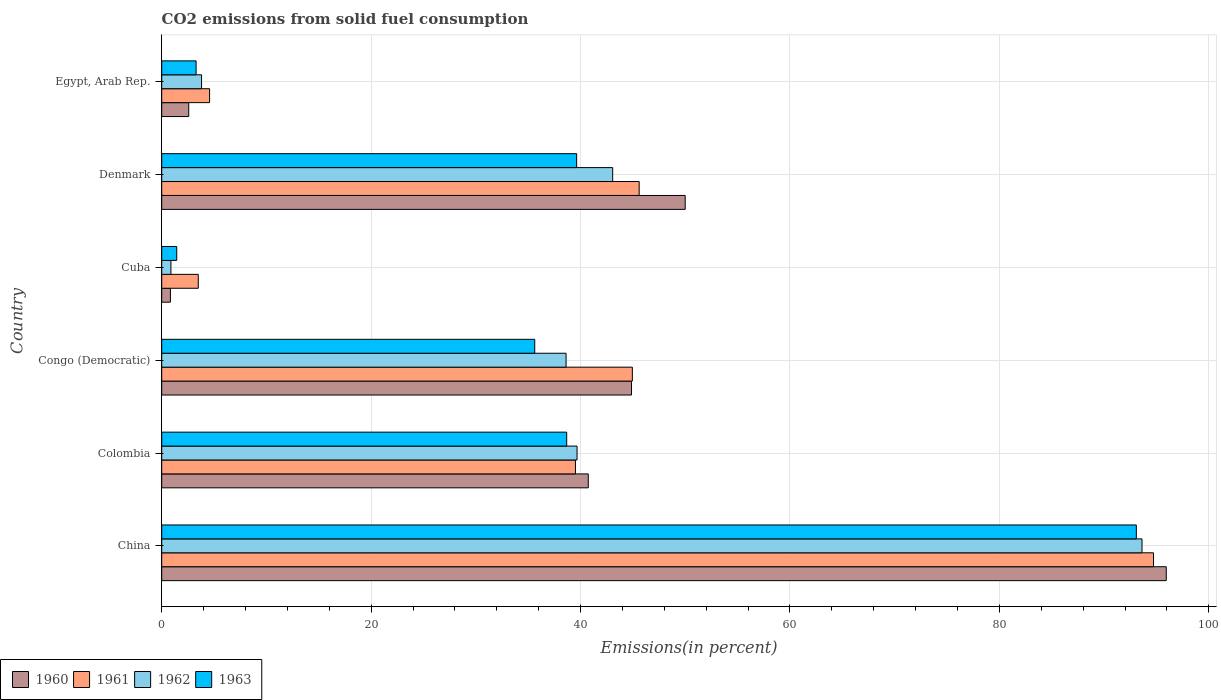How many different coloured bars are there?
Keep it short and to the point. 4. How many bars are there on the 5th tick from the bottom?
Offer a very short reply. 4. What is the label of the 6th group of bars from the top?
Your response must be concise. China. What is the total CO2 emitted in 1962 in Denmark?
Your response must be concise. 43.07. Across all countries, what is the maximum total CO2 emitted in 1960?
Provide a short and direct response. 95.93. Across all countries, what is the minimum total CO2 emitted in 1962?
Provide a succinct answer. 0.88. In which country was the total CO2 emitted in 1963 minimum?
Your answer should be very brief. Cuba. What is the total total CO2 emitted in 1962 in the graph?
Your answer should be very brief. 219.66. What is the difference between the total CO2 emitted in 1963 in Cuba and that in Egypt, Arab Rep.?
Your answer should be compact. -1.85. What is the difference between the total CO2 emitted in 1961 in Egypt, Arab Rep. and the total CO2 emitted in 1962 in Colombia?
Your answer should be very brief. -35.09. What is the average total CO2 emitted in 1963 per country?
Your answer should be compact. 35.29. What is the difference between the total CO2 emitted in 1960 and total CO2 emitted in 1962 in Egypt, Arab Rep.?
Provide a succinct answer. -1.22. What is the ratio of the total CO2 emitted in 1963 in Colombia to that in Egypt, Arab Rep.?
Keep it short and to the point. 11.78. Is the difference between the total CO2 emitted in 1960 in Colombia and Congo (Democratic) greater than the difference between the total CO2 emitted in 1962 in Colombia and Congo (Democratic)?
Make the answer very short. No. What is the difference between the highest and the second highest total CO2 emitted in 1963?
Make the answer very short. 53.45. What is the difference between the highest and the lowest total CO2 emitted in 1961?
Your response must be concise. 91.23. Is the sum of the total CO2 emitted in 1960 in Cuba and Egypt, Arab Rep. greater than the maximum total CO2 emitted in 1962 across all countries?
Your response must be concise. No. Is it the case that in every country, the sum of the total CO2 emitted in 1963 and total CO2 emitted in 1961 is greater than the sum of total CO2 emitted in 1960 and total CO2 emitted in 1962?
Offer a terse response. No. What does the 2nd bar from the top in Egypt, Arab Rep. represents?
Your answer should be very brief. 1962. What does the 3rd bar from the bottom in China represents?
Your answer should be compact. 1962. Is it the case that in every country, the sum of the total CO2 emitted in 1960 and total CO2 emitted in 1961 is greater than the total CO2 emitted in 1963?
Provide a short and direct response. Yes. Does the graph contain any zero values?
Make the answer very short. No. Does the graph contain grids?
Keep it short and to the point. Yes. Where does the legend appear in the graph?
Your answer should be very brief. Bottom left. What is the title of the graph?
Keep it short and to the point. CO2 emissions from solid fuel consumption. What is the label or title of the X-axis?
Offer a very short reply. Emissions(in percent). What is the label or title of the Y-axis?
Your response must be concise. Country. What is the Emissions(in percent) in 1960 in China?
Make the answer very short. 95.93. What is the Emissions(in percent) in 1961 in China?
Your answer should be compact. 94.72. What is the Emissions(in percent) in 1962 in China?
Keep it short and to the point. 93.62. What is the Emissions(in percent) in 1963 in China?
Ensure brevity in your answer.  93.08. What is the Emissions(in percent) in 1960 in Colombia?
Ensure brevity in your answer.  40.74. What is the Emissions(in percent) of 1961 in Colombia?
Your response must be concise. 39.51. What is the Emissions(in percent) in 1962 in Colombia?
Make the answer very short. 39.66. What is the Emissions(in percent) in 1963 in Colombia?
Keep it short and to the point. 38.68. What is the Emissions(in percent) of 1960 in Congo (Democratic)?
Your response must be concise. 44.87. What is the Emissions(in percent) in 1961 in Congo (Democratic)?
Your response must be concise. 44.95. What is the Emissions(in percent) of 1962 in Congo (Democratic)?
Your answer should be compact. 38.62. What is the Emissions(in percent) in 1963 in Congo (Democratic)?
Provide a succinct answer. 35.62. What is the Emissions(in percent) in 1960 in Cuba?
Your answer should be very brief. 0.83. What is the Emissions(in percent) of 1961 in Cuba?
Your answer should be compact. 3.49. What is the Emissions(in percent) in 1962 in Cuba?
Ensure brevity in your answer.  0.88. What is the Emissions(in percent) in 1963 in Cuba?
Give a very brief answer. 1.43. What is the Emissions(in percent) of 1960 in Denmark?
Make the answer very short. 49.99. What is the Emissions(in percent) of 1961 in Denmark?
Offer a very short reply. 45.6. What is the Emissions(in percent) of 1962 in Denmark?
Your answer should be very brief. 43.07. What is the Emissions(in percent) in 1963 in Denmark?
Your answer should be compact. 39.63. What is the Emissions(in percent) of 1960 in Egypt, Arab Rep.?
Your answer should be compact. 2.58. What is the Emissions(in percent) of 1961 in Egypt, Arab Rep.?
Your answer should be compact. 4.57. What is the Emissions(in percent) of 1962 in Egypt, Arab Rep.?
Offer a terse response. 3.81. What is the Emissions(in percent) of 1963 in Egypt, Arab Rep.?
Give a very brief answer. 3.28. Across all countries, what is the maximum Emissions(in percent) of 1960?
Offer a very short reply. 95.93. Across all countries, what is the maximum Emissions(in percent) in 1961?
Provide a short and direct response. 94.72. Across all countries, what is the maximum Emissions(in percent) in 1962?
Your answer should be compact. 93.62. Across all countries, what is the maximum Emissions(in percent) of 1963?
Provide a succinct answer. 93.08. Across all countries, what is the minimum Emissions(in percent) of 1960?
Keep it short and to the point. 0.83. Across all countries, what is the minimum Emissions(in percent) in 1961?
Your answer should be very brief. 3.49. Across all countries, what is the minimum Emissions(in percent) in 1962?
Ensure brevity in your answer.  0.88. Across all countries, what is the minimum Emissions(in percent) of 1963?
Provide a short and direct response. 1.43. What is the total Emissions(in percent) in 1960 in the graph?
Offer a very short reply. 234.94. What is the total Emissions(in percent) of 1961 in the graph?
Provide a short and direct response. 232.84. What is the total Emissions(in percent) of 1962 in the graph?
Give a very brief answer. 219.66. What is the total Emissions(in percent) in 1963 in the graph?
Offer a terse response. 211.72. What is the difference between the Emissions(in percent) in 1960 in China and that in Colombia?
Provide a short and direct response. 55.2. What is the difference between the Emissions(in percent) in 1961 in China and that in Colombia?
Make the answer very short. 55.2. What is the difference between the Emissions(in percent) in 1962 in China and that in Colombia?
Make the answer very short. 53.96. What is the difference between the Emissions(in percent) in 1963 in China and that in Colombia?
Make the answer very short. 54.4. What is the difference between the Emissions(in percent) of 1960 in China and that in Congo (Democratic)?
Offer a very short reply. 51.07. What is the difference between the Emissions(in percent) of 1961 in China and that in Congo (Democratic)?
Give a very brief answer. 49.77. What is the difference between the Emissions(in percent) in 1962 in China and that in Congo (Democratic)?
Your answer should be very brief. 55. What is the difference between the Emissions(in percent) in 1963 in China and that in Congo (Democratic)?
Give a very brief answer. 57.45. What is the difference between the Emissions(in percent) in 1960 in China and that in Cuba?
Provide a short and direct response. 95.11. What is the difference between the Emissions(in percent) in 1961 in China and that in Cuba?
Offer a terse response. 91.23. What is the difference between the Emissions(in percent) in 1962 in China and that in Cuba?
Provide a succinct answer. 92.74. What is the difference between the Emissions(in percent) in 1963 in China and that in Cuba?
Provide a succinct answer. 91.64. What is the difference between the Emissions(in percent) in 1960 in China and that in Denmark?
Ensure brevity in your answer.  45.94. What is the difference between the Emissions(in percent) in 1961 in China and that in Denmark?
Your response must be concise. 49.12. What is the difference between the Emissions(in percent) in 1962 in China and that in Denmark?
Provide a short and direct response. 50.55. What is the difference between the Emissions(in percent) of 1963 in China and that in Denmark?
Provide a short and direct response. 53.45. What is the difference between the Emissions(in percent) in 1960 in China and that in Egypt, Arab Rep.?
Your answer should be compact. 93.35. What is the difference between the Emissions(in percent) in 1961 in China and that in Egypt, Arab Rep.?
Give a very brief answer. 90.15. What is the difference between the Emissions(in percent) in 1962 in China and that in Egypt, Arab Rep.?
Offer a very short reply. 89.81. What is the difference between the Emissions(in percent) in 1963 in China and that in Egypt, Arab Rep.?
Provide a succinct answer. 89.79. What is the difference between the Emissions(in percent) in 1960 in Colombia and that in Congo (Democratic)?
Provide a short and direct response. -4.13. What is the difference between the Emissions(in percent) of 1961 in Colombia and that in Congo (Democratic)?
Provide a succinct answer. -5.43. What is the difference between the Emissions(in percent) of 1962 in Colombia and that in Congo (Democratic)?
Provide a succinct answer. 1.05. What is the difference between the Emissions(in percent) of 1963 in Colombia and that in Congo (Democratic)?
Offer a terse response. 3.05. What is the difference between the Emissions(in percent) in 1960 in Colombia and that in Cuba?
Give a very brief answer. 39.91. What is the difference between the Emissions(in percent) of 1961 in Colombia and that in Cuba?
Provide a succinct answer. 36.02. What is the difference between the Emissions(in percent) of 1962 in Colombia and that in Cuba?
Keep it short and to the point. 38.78. What is the difference between the Emissions(in percent) in 1963 in Colombia and that in Cuba?
Provide a succinct answer. 37.24. What is the difference between the Emissions(in percent) in 1960 in Colombia and that in Denmark?
Offer a terse response. -9.26. What is the difference between the Emissions(in percent) of 1961 in Colombia and that in Denmark?
Give a very brief answer. -6.08. What is the difference between the Emissions(in percent) in 1962 in Colombia and that in Denmark?
Provide a succinct answer. -3.4. What is the difference between the Emissions(in percent) of 1963 in Colombia and that in Denmark?
Provide a short and direct response. -0.95. What is the difference between the Emissions(in percent) in 1960 in Colombia and that in Egypt, Arab Rep.?
Offer a very short reply. 38.16. What is the difference between the Emissions(in percent) of 1961 in Colombia and that in Egypt, Arab Rep.?
Ensure brevity in your answer.  34.94. What is the difference between the Emissions(in percent) of 1962 in Colombia and that in Egypt, Arab Rep.?
Offer a very short reply. 35.86. What is the difference between the Emissions(in percent) in 1963 in Colombia and that in Egypt, Arab Rep.?
Keep it short and to the point. 35.39. What is the difference between the Emissions(in percent) in 1960 in Congo (Democratic) and that in Cuba?
Make the answer very short. 44.04. What is the difference between the Emissions(in percent) of 1961 in Congo (Democratic) and that in Cuba?
Ensure brevity in your answer.  41.45. What is the difference between the Emissions(in percent) in 1962 in Congo (Democratic) and that in Cuba?
Give a very brief answer. 37.74. What is the difference between the Emissions(in percent) in 1963 in Congo (Democratic) and that in Cuba?
Offer a terse response. 34.19. What is the difference between the Emissions(in percent) of 1960 in Congo (Democratic) and that in Denmark?
Provide a short and direct response. -5.13. What is the difference between the Emissions(in percent) in 1961 in Congo (Democratic) and that in Denmark?
Your answer should be compact. -0.65. What is the difference between the Emissions(in percent) in 1962 in Congo (Democratic) and that in Denmark?
Provide a short and direct response. -4.45. What is the difference between the Emissions(in percent) in 1963 in Congo (Democratic) and that in Denmark?
Make the answer very short. -4. What is the difference between the Emissions(in percent) in 1960 in Congo (Democratic) and that in Egypt, Arab Rep.?
Keep it short and to the point. 42.28. What is the difference between the Emissions(in percent) in 1961 in Congo (Democratic) and that in Egypt, Arab Rep.?
Your answer should be compact. 40.37. What is the difference between the Emissions(in percent) of 1962 in Congo (Democratic) and that in Egypt, Arab Rep.?
Give a very brief answer. 34.81. What is the difference between the Emissions(in percent) of 1963 in Congo (Democratic) and that in Egypt, Arab Rep.?
Make the answer very short. 32.34. What is the difference between the Emissions(in percent) in 1960 in Cuba and that in Denmark?
Provide a succinct answer. -49.16. What is the difference between the Emissions(in percent) of 1961 in Cuba and that in Denmark?
Provide a short and direct response. -42.11. What is the difference between the Emissions(in percent) of 1962 in Cuba and that in Denmark?
Your answer should be very brief. -42.19. What is the difference between the Emissions(in percent) in 1963 in Cuba and that in Denmark?
Your answer should be very brief. -38.19. What is the difference between the Emissions(in percent) of 1960 in Cuba and that in Egypt, Arab Rep.?
Your answer should be compact. -1.75. What is the difference between the Emissions(in percent) in 1961 in Cuba and that in Egypt, Arab Rep.?
Offer a very short reply. -1.08. What is the difference between the Emissions(in percent) of 1962 in Cuba and that in Egypt, Arab Rep.?
Offer a very short reply. -2.93. What is the difference between the Emissions(in percent) of 1963 in Cuba and that in Egypt, Arab Rep.?
Make the answer very short. -1.85. What is the difference between the Emissions(in percent) in 1960 in Denmark and that in Egypt, Arab Rep.?
Provide a short and direct response. 47.41. What is the difference between the Emissions(in percent) in 1961 in Denmark and that in Egypt, Arab Rep.?
Your answer should be very brief. 41.03. What is the difference between the Emissions(in percent) of 1962 in Denmark and that in Egypt, Arab Rep.?
Your response must be concise. 39.26. What is the difference between the Emissions(in percent) in 1963 in Denmark and that in Egypt, Arab Rep.?
Offer a very short reply. 36.34. What is the difference between the Emissions(in percent) of 1960 in China and the Emissions(in percent) of 1961 in Colombia?
Your answer should be compact. 56.42. What is the difference between the Emissions(in percent) of 1960 in China and the Emissions(in percent) of 1962 in Colombia?
Your answer should be compact. 56.27. What is the difference between the Emissions(in percent) of 1960 in China and the Emissions(in percent) of 1963 in Colombia?
Keep it short and to the point. 57.26. What is the difference between the Emissions(in percent) of 1961 in China and the Emissions(in percent) of 1962 in Colombia?
Provide a short and direct response. 55.05. What is the difference between the Emissions(in percent) in 1961 in China and the Emissions(in percent) in 1963 in Colombia?
Make the answer very short. 56.04. What is the difference between the Emissions(in percent) in 1962 in China and the Emissions(in percent) in 1963 in Colombia?
Keep it short and to the point. 54.94. What is the difference between the Emissions(in percent) in 1960 in China and the Emissions(in percent) in 1961 in Congo (Democratic)?
Your answer should be compact. 50.99. What is the difference between the Emissions(in percent) in 1960 in China and the Emissions(in percent) in 1962 in Congo (Democratic)?
Give a very brief answer. 57.32. What is the difference between the Emissions(in percent) in 1960 in China and the Emissions(in percent) in 1963 in Congo (Democratic)?
Give a very brief answer. 60.31. What is the difference between the Emissions(in percent) of 1961 in China and the Emissions(in percent) of 1962 in Congo (Democratic)?
Make the answer very short. 56.1. What is the difference between the Emissions(in percent) of 1961 in China and the Emissions(in percent) of 1963 in Congo (Democratic)?
Provide a succinct answer. 59.09. What is the difference between the Emissions(in percent) of 1962 in China and the Emissions(in percent) of 1963 in Congo (Democratic)?
Give a very brief answer. 58. What is the difference between the Emissions(in percent) of 1960 in China and the Emissions(in percent) of 1961 in Cuba?
Make the answer very short. 92.44. What is the difference between the Emissions(in percent) in 1960 in China and the Emissions(in percent) in 1962 in Cuba?
Offer a terse response. 95.05. What is the difference between the Emissions(in percent) of 1960 in China and the Emissions(in percent) of 1963 in Cuba?
Your response must be concise. 94.5. What is the difference between the Emissions(in percent) in 1961 in China and the Emissions(in percent) in 1962 in Cuba?
Keep it short and to the point. 93.84. What is the difference between the Emissions(in percent) in 1961 in China and the Emissions(in percent) in 1963 in Cuba?
Offer a terse response. 93.28. What is the difference between the Emissions(in percent) in 1962 in China and the Emissions(in percent) in 1963 in Cuba?
Make the answer very short. 92.19. What is the difference between the Emissions(in percent) in 1960 in China and the Emissions(in percent) in 1961 in Denmark?
Your answer should be very brief. 50.34. What is the difference between the Emissions(in percent) of 1960 in China and the Emissions(in percent) of 1962 in Denmark?
Offer a terse response. 52.87. What is the difference between the Emissions(in percent) of 1960 in China and the Emissions(in percent) of 1963 in Denmark?
Offer a terse response. 56.31. What is the difference between the Emissions(in percent) in 1961 in China and the Emissions(in percent) in 1962 in Denmark?
Ensure brevity in your answer.  51.65. What is the difference between the Emissions(in percent) of 1961 in China and the Emissions(in percent) of 1963 in Denmark?
Provide a short and direct response. 55.09. What is the difference between the Emissions(in percent) of 1962 in China and the Emissions(in percent) of 1963 in Denmark?
Give a very brief answer. 53.99. What is the difference between the Emissions(in percent) of 1960 in China and the Emissions(in percent) of 1961 in Egypt, Arab Rep.?
Ensure brevity in your answer.  91.36. What is the difference between the Emissions(in percent) in 1960 in China and the Emissions(in percent) in 1962 in Egypt, Arab Rep.?
Provide a succinct answer. 92.13. What is the difference between the Emissions(in percent) of 1960 in China and the Emissions(in percent) of 1963 in Egypt, Arab Rep.?
Ensure brevity in your answer.  92.65. What is the difference between the Emissions(in percent) in 1961 in China and the Emissions(in percent) in 1962 in Egypt, Arab Rep.?
Your answer should be compact. 90.91. What is the difference between the Emissions(in percent) of 1961 in China and the Emissions(in percent) of 1963 in Egypt, Arab Rep.?
Make the answer very short. 91.43. What is the difference between the Emissions(in percent) in 1962 in China and the Emissions(in percent) in 1963 in Egypt, Arab Rep.?
Keep it short and to the point. 90.34. What is the difference between the Emissions(in percent) of 1960 in Colombia and the Emissions(in percent) of 1961 in Congo (Democratic)?
Offer a very short reply. -4.21. What is the difference between the Emissions(in percent) of 1960 in Colombia and the Emissions(in percent) of 1962 in Congo (Democratic)?
Your answer should be compact. 2.12. What is the difference between the Emissions(in percent) in 1960 in Colombia and the Emissions(in percent) in 1963 in Congo (Democratic)?
Offer a terse response. 5.11. What is the difference between the Emissions(in percent) of 1961 in Colombia and the Emissions(in percent) of 1962 in Congo (Democratic)?
Your answer should be compact. 0.9. What is the difference between the Emissions(in percent) of 1961 in Colombia and the Emissions(in percent) of 1963 in Congo (Democratic)?
Give a very brief answer. 3.89. What is the difference between the Emissions(in percent) of 1962 in Colombia and the Emissions(in percent) of 1963 in Congo (Democratic)?
Give a very brief answer. 4.04. What is the difference between the Emissions(in percent) of 1960 in Colombia and the Emissions(in percent) of 1961 in Cuba?
Give a very brief answer. 37.25. What is the difference between the Emissions(in percent) of 1960 in Colombia and the Emissions(in percent) of 1962 in Cuba?
Ensure brevity in your answer.  39.86. What is the difference between the Emissions(in percent) of 1960 in Colombia and the Emissions(in percent) of 1963 in Cuba?
Make the answer very short. 39.3. What is the difference between the Emissions(in percent) in 1961 in Colombia and the Emissions(in percent) in 1962 in Cuba?
Offer a terse response. 38.63. What is the difference between the Emissions(in percent) of 1961 in Colombia and the Emissions(in percent) of 1963 in Cuba?
Your answer should be compact. 38.08. What is the difference between the Emissions(in percent) in 1962 in Colombia and the Emissions(in percent) in 1963 in Cuba?
Your answer should be very brief. 38.23. What is the difference between the Emissions(in percent) of 1960 in Colombia and the Emissions(in percent) of 1961 in Denmark?
Make the answer very short. -4.86. What is the difference between the Emissions(in percent) in 1960 in Colombia and the Emissions(in percent) in 1962 in Denmark?
Offer a very short reply. -2.33. What is the difference between the Emissions(in percent) in 1960 in Colombia and the Emissions(in percent) in 1963 in Denmark?
Your answer should be compact. 1.11. What is the difference between the Emissions(in percent) of 1961 in Colombia and the Emissions(in percent) of 1962 in Denmark?
Keep it short and to the point. -3.56. What is the difference between the Emissions(in percent) in 1961 in Colombia and the Emissions(in percent) in 1963 in Denmark?
Ensure brevity in your answer.  -0.11. What is the difference between the Emissions(in percent) in 1962 in Colombia and the Emissions(in percent) in 1963 in Denmark?
Your response must be concise. 0.04. What is the difference between the Emissions(in percent) in 1960 in Colombia and the Emissions(in percent) in 1961 in Egypt, Arab Rep.?
Give a very brief answer. 36.17. What is the difference between the Emissions(in percent) of 1960 in Colombia and the Emissions(in percent) of 1962 in Egypt, Arab Rep.?
Your answer should be compact. 36.93. What is the difference between the Emissions(in percent) of 1960 in Colombia and the Emissions(in percent) of 1963 in Egypt, Arab Rep.?
Your answer should be very brief. 37.45. What is the difference between the Emissions(in percent) of 1961 in Colombia and the Emissions(in percent) of 1962 in Egypt, Arab Rep.?
Your answer should be compact. 35.71. What is the difference between the Emissions(in percent) of 1961 in Colombia and the Emissions(in percent) of 1963 in Egypt, Arab Rep.?
Provide a succinct answer. 36.23. What is the difference between the Emissions(in percent) of 1962 in Colombia and the Emissions(in percent) of 1963 in Egypt, Arab Rep.?
Make the answer very short. 36.38. What is the difference between the Emissions(in percent) of 1960 in Congo (Democratic) and the Emissions(in percent) of 1961 in Cuba?
Provide a succinct answer. 41.37. What is the difference between the Emissions(in percent) in 1960 in Congo (Democratic) and the Emissions(in percent) in 1962 in Cuba?
Your answer should be very brief. 43.99. What is the difference between the Emissions(in percent) in 1960 in Congo (Democratic) and the Emissions(in percent) in 1963 in Cuba?
Offer a terse response. 43.43. What is the difference between the Emissions(in percent) in 1961 in Congo (Democratic) and the Emissions(in percent) in 1962 in Cuba?
Offer a terse response. 44.07. What is the difference between the Emissions(in percent) in 1961 in Congo (Democratic) and the Emissions(in percent) in 1963 in Cuba?
Give a very brief answer. 43.51. What is the difference between the Emissions(in percent) in 1962 in Congo (Democratic) and the Emissions(in percent) in 1963 in Cuba?
Provide a succinct answer. 37.18. What is the difference between the Emissions(in percent) of 1960 in Congo (Democratic) and the Emissions(in percent) of 1961 in Denmark?
Offer a terse response. -0.73. What is the difference between the Emissions(in percent) in 1960 in Congo (Democratic) and the Emissions(in percent) in 1962 in Denmark?
Your answer should be compact. 1.8. What is the difference between the Emissions(in percent) in 1960 in Congo (Democratic) and the Emissions(in percent) in 1963 in Denmark?
Make the answer very short. 5.24. What is the difference between the Emissions(in percent) of 1961 in Congo (Democratic) and the Emissions(in percent) of 1962 in Denmark?
Your response must be concise. 1.88. What is the difference between the Emissions(in percent) of 1961 in Congo (Democratic) and the Emissions(in percent) of 1963 in Denmark?
Make the answer very short. 5.32. What is the difference between the Emissions(in percent) in 1962 in Congo (Democratic) and the Emissions(in percent) in 1963 in Denmark?
Keep it short and to the point. -1.01. What is the difference between the Emissions(in percent) in 1960 in Congo (Democratic) and the Emissions(in percent) in 1961 in Egypt, Arab Rep.?
Give a very brief answer. 40.29. What is the difference between the Emissions(in percent) of 1960 in Congo (Democratic) and the Emissions(in percent) of 1962 in Egypt, Arab Rep.?
Offer a very short reply. 41.06. What is the difference between the Emissions(in percent) in 1960 in Congo (Democratic) and the Emissions(in percent) in 1963 in Egypt, Arab Rep.?
Make the answer very short. 41.58. What is the difference between the Emissions(in percent) in 1961 in Congo (Democratic) and the Emissions(in percent) in 1962 in Egypt, Arab Rep.?
Your answer should be very brief. 41.14. What is the difference between the Emissions(in percent) in 1961 in Congo (Democratic) and the Emissions(in percent) in 1963 in Egypt, Arab Rep.?
Provide a succinct answer. 41.66. What is the difference between the Emissions(in percent) in 1962 in Congo (Democratic) and the Emissions(in percent) in 1963 in Egypt, Arab Rep.?
Ensure brevity in your answer.  35.33. What is the difference between the Emissions(in percent) of 1960 in Cuba and the Emissions(in percent) of 1961 in Denmark?
Your response must be concise. -44.77. What is the difference between the Emissions(in percent) of 1960 in Cuba and the Emissions(in percent) of 1962 in Denmark?
Your answer should be compact. -42.24. What is the difference between the Emissions(in percent) in 1960 in Cuba and the Emissions(in percent) in 1963 in Denmark?
Provide a short and direct response. -38.8. What is the difference between the Emissions(in percent) in 1961 in Cuba and the Emissions(in percent) in 1962 in Denmark?
Keep it short and to the point. -39.58. What is the difference between the Emissions(in percent) in 1961 in Cuba and the Emissions(in percent) in 1963 in Denmark?
Your answer should be very brief. -36.14. What is the difference between the Emissions(in percent) in 1962 in Cuba and the Emissions(in percent) in 1963 in Denmark?
Offer a very short reply. -38.75. What is the difference between the Emissions(in percent) in 1960 in Cuba and the Emissions(in percent) in 1961 in Egypt, Arab Rep.?
Provide a short and direct response. -3.74. What is the difference between the Emissions(in percent) in 1960 in Cuba and the Emissions(in percent) in 1962 in Egypt, Arab Rep.?
Your answer should be very brief. -2.98. What is the difference between the Emissions(in percent) in 1960 in Cuba and the Emissions(in percent) in 1963 in Egypt, Arab Rep.?
Your response must be concise. -2.45. What is the difference between the Emissions(in percent) of 1961 in Cuba and the Emissions(in percent) of 1962 in Egypt, Arab Rep.?
Your response must be concise. -0.31. What is the difference between the Emissions(in percent) in 1961 in Cuba and the Emissions(in percent) in 1963 in Egypt, Arab Rep.?
Make the answer very short. 0.21. What is the difference between the Emissions(in percent) of 1962 in Cuba and the Emissions(in percent) of 1963 in Egypt, Arab Rep.?
Offer a very short reply. -2.4. What is the difference between the Emissions(in percent) in 1960 in Denmark and the Emissions(in percent) in 1961 in Egypt, Arab Rep.?
Your answer should be compact. 45.42. What is the difference between the Emissions(in percent) of 1960 in Denmark and the Emissions(in percent) of 1962 in Egypt, Arab Rep.?
Your response must be concise. 46.19. What is the difference between the Emissions(in percent) in 1960 in Denmark and the Emissions(in percent) in 1963 in Egypt, Arab Rep.?
Your answer should be compact. 46.71. What is the difference between the Emissions(in percent) in 1961 in Denmark and the Emissions(in percent) in 1962 in Egypt, Arab Rep.?
Ensure brevity in your answer.  41.79. What is the difference between the Emissions(in percent) in 1961 in Denmark and the Emissions(in percent) in 1963 in Egypt, Arab Rep.?
Provide a short and direct response. 42.31. What is the difference between the Emissions(in percent) of 1962 in Denmark and the Emissions(in percent) of 1963 in Egypt, Arab Rep.?
Ensure brevity in your answer.  39.79. What is the average Emissions(in percent) in 1960 per country?
Ensure brevity in your answer.  39.16. What is the average Emissions(in percent) of 1961 per country?
Your answer should be compact. 38.81. What is the average Emissions(in percent) in 1962 per country?
Give a very brief answer. 36.61. What is the average Emissions(in percent) in 1963 per country?
Your response must be concise. 35.29. What is the difference between the Emissions(in percent) in 1960 and Emissions(in percent) in 1961 in China?
Ensure brevity in your answer.  1.22. What is the difference between the Emissions(in percent) of 1960 and Emissions(in percent) of 1962 in China?
Give a very brief answer. 2.32. What is the difference between the Emissions(in percent) in 1960 and Emissions(in percent) in 1963 in China?
Provide a short and direct response. 2.86. What is the difference between the Emissions(in percent) of 1961 and Emissions(in percent) of 1962 in China?
Your answer should be very brief. 1.1. What is the difference between the Emissions(in percent) of 1961 and Emissions(in percent) of 1963 in China?
Keep it short and to the point. 1.64. What is the difference between the Emissions(in percent) of 1962 and Emissions(in percent) of 1963 in China?
Keep it short and to the point. 0.54. What is the difference between the Emissions(in percent) of 1960 and Emissions(in percent) of 1961 in Colombia?
Your response must be concise. 1.22. What is the difference between the Emissions(in percent) of 1960 and Emissions(in percent) of 1962 in Colombia?
Keep it short and to the point. 1.07. What is the difference between the Emissions(in percent) in 1960 and Emissions(in percent) in 1963 in Colombia?
Offer a terse response. 2.06. What is the difference between the Emissions(in percent) in 1961 and Emissions(in percent) in 1962 in Colombia?
Your answer should be compact. -0.15. What is the difference between the Emissions(in percent) of 1961 and Emissions(in percent) of 1963 in Colombia?
Offer a very short reply. 0.84. What is the difference between the Emissions(in percent) in 1962 and Emissions(in percent) in 1963 in Colombia?
Offer a terse response. 0.99. What is the difference between the Emissions(in percent) of 1960 and Emissions(in percent) of 1961 in Congo (Democratic)?
Your response must be concise. -0.08. What is the difference between the Emissions(in percent) of 1960 and Emissions(in percent) of 1962 in Congo (Democratic)?
Your answer should be very brief. 6.25. What is the difference between the Emissions(in percent) in 1960 and Emissions(in percent) in 1963 in Congo (Democratic)?
Your answer should be very brief. 9.24. What is the difference between the Emissions(in percent) in 1961 and Emissions(in percent) in 1962 in Congo (Democratic)?
Make the answer very short. 6.33. What is the difference between the Emissions(in percent) of 1961 and Emissions(in percent) of 1963 in Congo (Democratic)?
Give a very brief answer. 9.32. What is the difference between the Emissions(in percent) of 1962 and Emissions(in percent) of 1963 in Congo (Democratic)?
Your response must be concise. 2.99. What is the difference between the Emissions(in percent) of 1960 and Emissions(in percent) of 1961 in Cuba?
Offer a very short reply. -2.66. What is the difference between the Emissions(in percent) of 1960 and Emissions(in percent) of 1962 in Cuba?
Give a very brief answer. -0.05. What is the difference between the Emissions(in percent) in 1960 and Emissions(in percent) in 1963 in Cuba?
Provide a short and direct response. -0.6. What is the difference between the Emissions(in percent) of 1961 and Emissions(in percent) of 1962 in Cuba?
Provide a succinct answer. 2.61. What is the difference between the Emissions(in percent) in 1961 and Emissions(in percent) in 1963 in Cuba?
Offer a terse response. 2.06. What is the difference between the Emissions(in percent) in 1962 and Emissions(in percent) in 1963 in Cuba?
Your answer should be very brief. -0.55. What is the difference between the Emissions(in percent) in 1960 and Emissions(in percent) in 1961 in Denmark?
Keep it short and to the point. 4.4. What is the difference between the Emissions(in percent) in 1960 and Emissions(in percent) in 1962 in Denmark?
Provide a succinct answer. 6.93. What is the difference between the Emissions(in percent) of 1960 and Emissions(in percent) of 1963 in Denmark?
Give a very brief answer. 10.37. What is the difference between the Emissions(in percent) in 1961 and Emissions(in percent) in 1962 in Denmark?
Give a very brief answer. 2.53. What is the difference between the Emissions(in percent) of 1961 and Emissions(in percent) of 1963 in Denmark?
Provide a short and direct response. 5.97. What is the difference between the Emissions(in percent) of 1962 and Emissions(in percent) of 1963 in Denmark?
Make the answer very short. 3.44. What is the difference between the Emissions(in percent) of 1960 and Emissions(in percent) of 1961 in Egypt, Arab Rep.?
Make the answer very short. -1.99. What is the difference between the Emissions(in percent) of 1960 and Emissions(in percent) of 1962 in Egypt, Arab Rep.?
Your response must be concise. -1.22. What is the difference between the Emissions(in percent) in 1960 and Emissions(in percent) in 1963 in Egypt, Arab Rep.?
Make the answer very short. -0.7. What is the difference between the Emissions(in percent) in 1961 and Emissions(in percent) in 1962 in Egypt, Arab Rep.?
Make the answer very short. 0.76. What is the difference between the Emissions(in percent) of 1961 and Emissions(in percent) of 1963 in Egypt, Arab Rep.?
Provide a short and direct response. 1.29. What is the difference between the Emissions(in percent) in 1962 and Emissions(in percent) in 1963 in Egypt, Arab Rep.?
Your answer should be very brief. 0.52. What is the ratio of the Emissions(in percent) of 1960 in China to that in Colombia?
Give a very brief answer. 2.35. What is the ratio of the Emissions(in percent) of 1961 in China to that in Colombia?
Offer a very short reply. 2.4. What is the ratio of the Emissions(in percent) in 1962 in China to that in Colombia?
Offer a very short reply. 2.36. What is the ratio of the Emissions(in percent) in 1963 in China to that in Colombia?
Make the answer very short. 2.41. What is the ratio of the Emissions(in percent) in 1960 in China to that in Congo (Democratic)?
Give a very brief answer. 2.14. What is the ratio of the Emissions(in percent) of 1961 in China to that in Congo (Democratic)?
Keep it short and to the point. 2.11. What is the ratio of the Emissions(in percent) in 1962 in China to that in Congo (Democratic)?
Offer a terse response. 2.42. What is the ratio of the Emissions(in percent) in 1963 in China to that in Congo (Democratic)?
Keep it short and to the point. 2.61. What is the ratio of the Emissions(in percent) in 1960 in China to that in Cuba?
Keep it short and to the point. 115.62. What is the ratio of the Emissions(in percent) in 1961 in China to that in Cuba?
Your answer should be compact. 27.13. What is the ratio of the Emissions(in percent) in 1962 in China to that in Cuba?
Your response must be concise. 106.4. What is the ratio of the Emissions(in percent) in 1963 in China to that in Cuba?
Provide a short and direct response. 64.9. What is the ratio of the Emissions(in percent) in 1960 in China to that in Denmark?
Offer a very short reply. 1.92. What is the ratio of the Emissions(in percent) of 1961 in China to that in Denmark?
Your response must be concise. 2.08. What is the ratio of the Emissions(in percent) of 1962 in China to that in Denmark?
Offer a terse response. 2.17. What is the ratio of the Emissions(in percent) of 1963 in China to that in Denmark?
Your answer should be very brief. 2.35. What is the ratio of the Emissions(in percent) in 1960 in China to that in Egypt, Arab Rep.?
Your response must be concise. 37.17. What is the ratio of the Emissions(in percent) of 1961 in China to that in Egypt, Arab Rep.?
Your answer should be compact. 20.72. What is the ratio of the Emissions(in percent) in 1962 in China to that in Egypt, Arab Rep.?
Your answer should be very brief. 24.6. What is the ratio of the Emissions(in percent) of 1963 in China to that in Egypt, Arab Rep.?
Offer a terse response. 28.35. What is the ratio of the Emissions(in percent) of 1960 in Colombia to that in Congo (Democratic)?
Your answer should be very brief. 0.91. What is the ratio of the Emissions(in percent) in 1961 in Colombia to that in Congo (Democratic)?
Ensure brevity in your answer.  0.88. What is the ratio of the Emissions(in percent) of 1962 in Colombia to that in Congo (Democratic)?
Provide a short and direct response. 1.03. What is the ratio of the Emissions(in percent) of 1963 in Colombia to that in Congo (Democratic)?
Your answer should be compact. 1.09. What is the ratio of the Emissions(in percent) of 1960 in Colombia to that in Cuba?
Ensure brevity in your answer.  49.1. What is the ratio of the Emissions(in percent) in 1961 in Colombia to that in Cuba?
Your answer should be compact. 11.32. What is the ratio of the Emissions(in percent) in 1962 in Colombia to that in Cuba?
Offer a very short reply. 45.08. What is the ratio of the Emissions(in percent) in 1963 in Colombia to that in Cuba?
Offer a terse response. 26.97. What is the ratio of the Emissions(in percent) in 1960 in Colombia to that in Denmark?
Give a very brief answer. 0.81. What is the ratio of the Emissions(in percent) in 1961 in Colombia to that in Denmark?
Ensure brevity in your answer.  0.87. What is the ratio of the Emissions(in percent) of 1962 in Colombia to that in Denmark?
Ensure brevity in your answer.  0.92. What is the ratio of the Emissions(in percent) of 1963 in Colombia to that in Denmark?
Offer a terse response. 0.98. What is the ratio of the Emissions(in percent) in 1960 in Colombia to that in Egypt, Arab Rep.?
Keep it short and to the point. 15.78. What is the ratio of the Emissions(in percent) in 1961 in Colombia to that in Egypt, Arab Rep.?
Keep it short and to the point. 8.64. What is the ratio of the Emissions(in percent) in 1962 in Colombia to that in Egypt, Arab Rep.?
Offer a terse response. 10.42. What is the ratio of the Emissions(in percent) in 1963 in Colombia to that in Egypt, Arab Rep.?
Ensure brevity in your answer.  11.78. What is the ratio of the Emissions(in percent) of 1960 in Congo (Democratic) to that in Cuba?
Your answer should be compact. 54.07. What is the ratio of the Emissions(in percent) of 1961 in Congo (Democratic) to that in Cuba?
Give a very brief answer. 12.87. What is the ratio of the Emissions(in percent) in 1962 in Congo (Democratic) to that in Cuba?
Your answer should be very brief. 43.89. What is the ratio of the Emissions(in percent) of 1963 in Congo (Democratic) to that in Cuba?
Your answer should be compact. 24.84. What is the ratio of the Emissions(in percent) of 1960 in Congo (Democratic) to that in Denmark?
Provide a short and direct response. 0.9. What is the ratio of the Emissions(in percent) of 1961 in Congo (Democratic) to that in Denmark?
Offer a very short reply. 0.99. What is the ratio of the Emissions(in percent) of 1962 in Congo (Democratic) to that in Denmark?
Make the answer very short. 0.9. What is the ratio of the Emissions(in percent) in 1963 in Congo (Democratic) to that in Denmark?
Your response must be concise. 0.9. What is the ratio of the Emissions(in percent) of 1960 in Congo (Democratic) to that in Egypt, Arab Rep.?
Ensure brevity in your answer.  17.38. What is the ratio of the Emissions(in percent) of 1961 in Congo (Democratic) to that in Egypt, Arab Rep.?
Ensure brevity in your answer.  9.83. What is the ratio of the Emissions(in percent) in 1962 in Congo (Democratic) to that in Egypt, Arab Rep.?
Keep it short and to the point. 10.15. What is the ratio of the Emissions(in percent) of 1963 in Congo (Democratic) to that in Egypt, Arab Rep.?
Make the answer very short. 10.85. What is the ratio of the Emissions(in percent) in 1960 in Cuba to that in Denmark?
Your answer should be very brief. 0.02. What is the ratio of the Emissions(in percent) of 1961 in Cuba to that in Denmark?
Offer a terse response. 0.08. What is the ratio of the Emissions(in percent) in 1962 in Cuba to that in Denmark?
Keep it short and to the point. 0.02. What is the ratio of the Emissions(in percent) of 1963 in Cuba to that in Denmark?
Offer a very short reply. 0.04. What is the ratio of the Emissions(in percent) in 1960 in Cuba to that in Egypt, Arab Rep.?
Your answer should be compact. 0.32. What is the ratio of the Emissions(in percent) of 1961 in Cuba to that in Egypt, Arab Rep.?
Your answer should be compact. 0.76. What is the ratio of the Emissions(in percent) of 1962 in Cuba to that in Egypt, Arab Rep.?
Give a very brief answer. 0.23. What is the ratio of the Emissions(in percent) in 1963 in Cuba to that in Egypt, Arab Rep.?
Your response must be concise. 0.44. What is the ratio of the Emissions(in percent) in 1960 in Denmark to that in Egypt, Arab Rep.?
Your answer should be very brief. 19.37. What is the ratio of the Emissions(in percent) of 1961 in Denmark to that in Egypt, Arab Rep.?
Your answer should be very brief. 9.98. What is the ratio of the Emissions(in percent) in 1962 in Denmark to that in Egypt, Arab Rep.?
Your answer should be compact. 11.32. What is the ratio of the Emissions(in percent) in 1963 in Denmark to that in Egypt, Arab Rep.?
Offer a very short reply. 12.07. What is the difference between the highest and the second highest Emissions(in percent) in 1960?
Offer a very short reply. 45.94. What is the difference between the highest and the second highest Emissions(in percent) in 1961?
Offer a terse response. 49.12. What is the difference between the highest and the second highest Emissions(in percent) in 1962?
Ensure brevity in your answer.  50.55. What is the difference between the highest and the second highest Emissions(in percent) of 1963?
Ensure brevity in your answer.  53.45. What is the difference between the highest and the lowest Emissions(in percent) of 1960?
Your answer should be very brief. 95.11. What is the difference between the highest and the lowest Emissions(in percent) of 1961?
Offer a terse response. 91.23. What is the difference between the highest and the lowest Emissions(in percent) in 1962?
Your answer should be very brief. 92.74. What is the difference between the highest and the lowest Emissions(in percent) in 1963?
Ensure brevity in your answer.  91.64. 